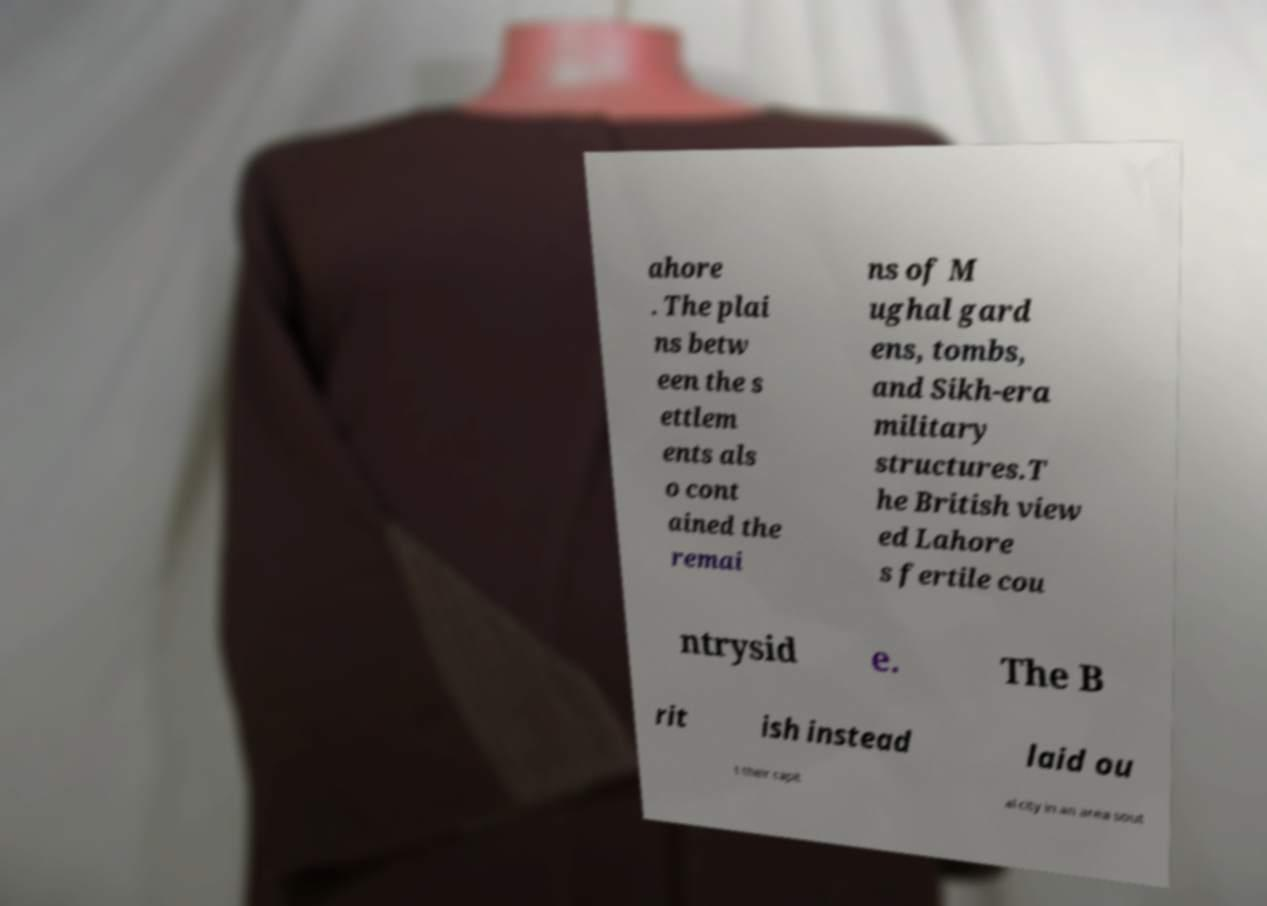Please identify and transcribe the text found in this image. ahore . The plai ns betw een the s ettlem ents als o cont ained the remai ns of M ughal gard ens, tombs, and Sikh-era military structures.T he British view ed Lahore s fertile cou ntrysid e. The B rit ish instead laid ou t their capit al city in an area sout 